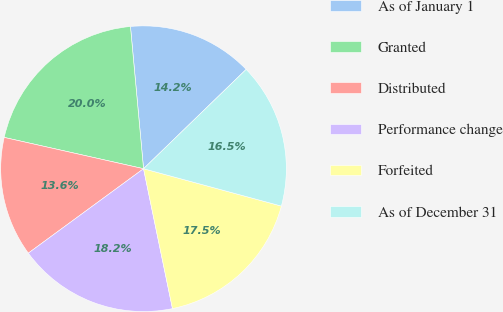<chart> <loc_0><loc_0><loc_500><loc_500><pie_chart><fcel>As of January 1<fcel>Granted<fcel>Distributed<fcel>Performance change<fcel>Forfeited<fcel>As of December 31<nl><fcel>14.22%<fcel>20.02%<fcel>13.58%<fcel>18.18%<fcel>17.54%<fcel>16.45%<nl></chart> 